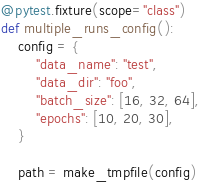Convert code to text. <code><loc_0><loc_0><loc_500><loc_500><_Python_>

@pytest.fixture(scope="class")
def multiple_runs_config():
    config = {
        "data_name": "test",
        "data_dir": "foo",
        "batch_size": [16, 32, 64],
        "epochs": [10, 20, 30],
    }

    path = make_tmpfile(config)</code> 